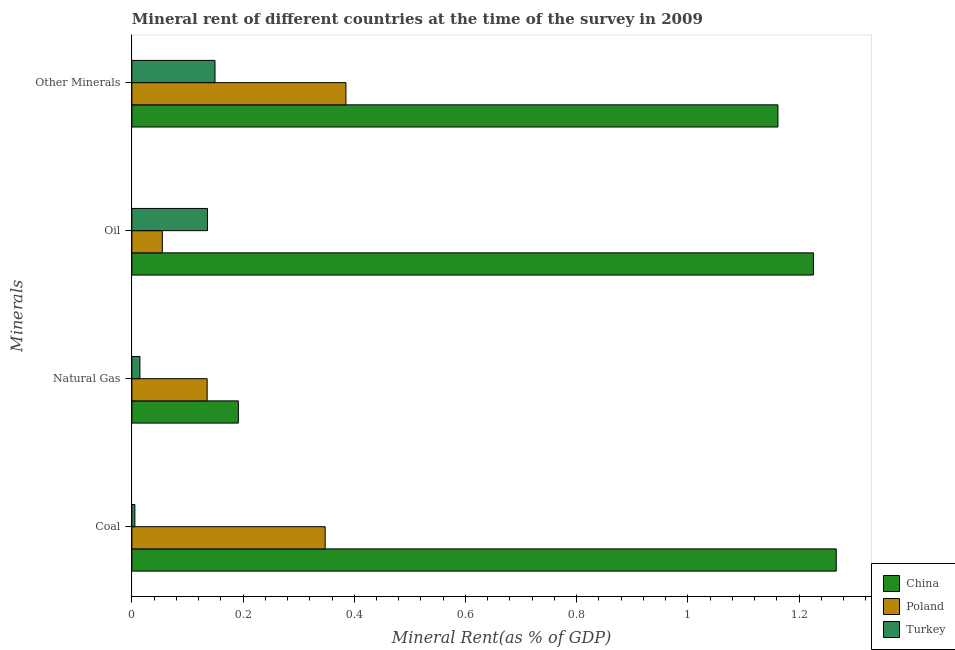Are the number of bars per tick equal to the number of legend labels?
Your response must be concise. Yes. Are the number of bars on each tick of the Y-axis equal?
Provide a succinct answer. Yes. How many bars are there on the 1st tick from the bottom?
Keep it short and to the point. 3. What is the label of the 3rd group of bars from the top?
Your response must be concise. Natural Gas. What is the coal rent in Turkey?
Offer a very short reply. 0.01. Across all countries, what is the maximum oil rent?
Provide a short and direct response. 1.23. Across all countries, what is the minimum  rent of other minerals?
Your answer should be very brief. 0.15. In which country was the natural gas rent maximum?
Ensure brevity in your answer.  China. In which country was the oil rent minimum?
Your response must be concise. Poland. What is the total  rent of other minerals in the graph?
Your answer should be very brief. 1.7. What is the difference between the natural gas rent in China and that in Turkey?
Ensure brevity in your answer.  0.18. What is the difference between the coal rent in Poland and the  rent of other minerals in Turkey?
Your response must be concise. 0.2. What is the average natural gas rent per country?
Provide a short and direct response. 0.11. What is the difference between the coal rent and  rent of other minerals in China?
Give a very brief answer. 0.1. What is the ratio of the coal rent in China to that in Poland?
Offer a very short reply. 3.64. Is the difference between the oil rent in China and Poland greater than the difference between the  rent of other minerals in China and Poland?
Keep it short and to the point. Yes. What is the difference between the highest and the second highest  rent of other minerals?
Offer a terse response. 0.78. What is the difference between the highest and the lowest coal rent?
Ensure brevity in your answer.  1.26. In how many countries, is the oil rent greater than the average oil rent taken over all countries?
Make the answer very short. 1. Is the sum of the oil rent in Poland and Turkey greater than the maximum coal rent across all countries?
Offer a terse response. No. Is it the case that in every country, the sum of the oil rent and natural gas rent is greater than the sum of coal rent and  rent of other minerals?
Keep it short and to the point. No. What does the 2nd bar from the bottom in Coal represents?
Your answer should be very brief. Poland. Is it the case that in every country, the sum of the coal rent and natural gas rent is greater than the oil rent?
Give a very brief answer. No. Are all the bars in the graph horizontal?
Your response must be concise. Yes. Does the graph contain grids?
Give a very brief answer. No. Where does the legend appear in the graph?
Your answer should be very brief. Bottom right. How many legend labels are there?
Offer a terse response. 3. How are the legend labels stacked?
Make the answer very short. Vertical. What is the title of the graph?
Make the answer very short. Mineral rent of different countries at the time of the survey in 2009. What is the label or title of the X-axis?
Keep it short and to the point. Mineral Rent(as % of GDP). What is the label or title of the Y-axis?
Your answer should be compact. Minerals. What is the Mineral Rent(as % of GDP) in China in Coal?
Your answer should be very brief. 1.27. What is the Mineral Rent(as % of GDP) in Poland in Coal?
Your answer should be compact. 0.35. What is the Mineral Rent(as % of GDP) of Turkey in Coal?
Provide a short and direct response. 0.01. What is the Mineral Rent(as % of GDP) of China in Natural Gas?
Keep it short and to the point. 0.19. What is the Mineral Rent(as % of GDP) of Poland in Natural Gas?
Offer a very short reply. 0.14. What is the Mineral Rent(as % of GDP) in Turkey in Natural Gas?
Offer a terse response. 0.01. What is the Mineral Rent(as % of GDP) of China in Oil?
Make the answer very short. 1.23. What is the Mineral Rent(as % of GDP) of Poland in Oil?
Your answer should be compact. 0.05. What is the Mineral Rent(as % of GDP) in Turkey in Oil?
Offer a terse response. 0.14. What is the Mineral Rent(as % of GDP) in China in Other Minerals?
Give a very brief answer. 1.16. What is the Mineral Rent(as % of GDP) of Poland in Other Minerals?
Make the answer very short. 0.39. What is the Mineral Rent(as % of GDP) of Turkey in Other Minerals?
Offer a terse response. 0.15. Across all Minerals, what is the maximum Mineral Rent(as % of GDP) in China?
Offer a terse response. 1.27. Across all Minerals, what is the maximum Mineral Rent(as % of GDP) in Poland?
Provide a succinct answer. 0.39. Across all Minerals, what is the maximum Mineral Rent(as % of GDP) of Turkey?
Give a very brief answer. 0.15. Across all Minerals, what is the minimum Mineral Rent(as % of GDP) of China?
Offer a very short reply. 0.19. Across all Minerals, what is the minimum Mineral Rent(as % of GDP) of Poland?
Your answer should be very brief. 0.05. Across all Minerals, what is the minimum Mineral Rent(as % of GDP) of Turkey?
Provide a short and direct response. 0.01. What is the total Mineral Rent(as % of GDP) of China in the graph?
Your answer should be very brief. 3.85. What is the total Mineral Rent(as % of GDP) of Poland in the graph?
Provide a succinct answer. 0.92. What is the total Mineral Rent(as % of GDP) in Turkey in the graph?
Make the answer very short. 0.31. What is the difference between the Mineral Rent(as % of GDP) of China in Coal and that in Natural Gas?
Your answer should be very brief. 1.08. What is the difference between the Mineral Rent(as % of GDP) of Poland in Coal and that in Natural Gas?
Keep it short and to the point. 0.21. What is the difference between the Mineral Rent(as % of GDP) in Turkey in Coal and that in Natural Gas?
Offer a terse response. -0.01. What is the difference between the Mineral Rent(as % of GDP) of China in Coal and that in Oil?
Provide a short and direct response. 0.04. What is the difference between the Mineral Rent(as % of GDP) in Poland in Coal and that in Oil?
Ensure brevity in your answer.  0.29. What is the difference between the Mineral Rent(as % of GDP) in Turkey in Coal and that in Oil?
Ensure brevity in your answer.  -0.13. What is the difference between the Mineral Rent(as % of GDP) in China in Coal and that in Other Minerals?
Ensure brevity in your answer.  0.1. What is the difference between the Mineral Rent(as % of GDP) of Poland in Coal and that in Other Minerals?
Offer a terse response. -0.04. What is the difference between the Mineral Rent(as % of GDP) of Turkey in Coal and that in Other Minerals?
Your answer should be compact. -0.14. What is the difference between the Mineral Rent(as % of GDP) in China in Natural Gas and that in Oil?
Offer a very short reply. -1.03. What is the difference between the Mineral Rent(as % of GDP) of Poland in Natural Gas and that in Oil?
Keep it short and to the point. 0.08. What is the difference between the Mineral Rent(as % of GDP) in Turkey in Natural Gas and that in Oil?
Make the answer very short. -0.12. What is the difference between the Mineral Rent(as % of GDP) of China in Natural Gas and that in Other Minerals?
Give a very brief answer. -0.97. What is the difference between the Mineral Rent(as % of GDP) in Poland in Natural Gas and that in Other Minerals?
Offer a very short reply. -0.25. What is the difference between the Mineral Rent(as % of GDP) in Turkey in Natural Gas and that in Other Minerals?
Give a very brief answer. -0.14. What is the difference between the Mineral Rent(as % of GDP) in China in Oil and that in Other Minerals?
Your answer should be compact. 0.06. What is the difference between the Mineral Rent(as % of GDP) in Poland in Oil and that in Other Minerals?
Make the answer very short. -0.33. What is the difference between the Mineral Rent(as % of GDP) of Turkey in Oil and that in Other Minerals?
Keep it short and to the point. -0.01. What is the difference between the Mineral Rent(as % of GDP) in China in Coal and the Mineral Rent(as % of GDP) in Poland in Natural Gas?
Offer a very short reply. 1.13. What is the difference between the Mineral Rent(as % of GDP) of China in Coal and the Mineral Rent(as % of GDP) of Turkey in Natural Gas?
Give a very brief answer. 1.25. What is the difference between the Mineral Rent(as % of GDP) of Poland in Coal and the Mineral Rent(as % of GDP) of Turkey in Natural Gas?
Offer a very short reply. 0.33. What is the difference between the Mineral Rent(as % of GDP) of China in Coal and the Mineral Rent(as % of GDP) of Poland in Oil?
Provide a succinct answer. 1.21. What is the difference between the Mineral Rent(as % of GDP) of China in Coal and the Mineral Rent(as % of GDP) of Turkey in Oil?
Offer a terse response. 1.13. What is the difference between the Mineral Rent(as % of GDP) of Poland in Coal and the Mineral Rent(as % of GDP) of Turkey in Oil?
Your answer should be compact. 0.21. What is the difference between the Mineral Rent(as % of GDP) of China in Coal and the Mineral Rent(as % of GDP) of Poland in Other Minerals?
Make the answer very short. 0.88. What is the difference between the Mineral Rent(as % of GDP) of China in Coal and the Mineral Rent(as % of GDP) of Turkey in Other Minerals?
Offer a terse response. 1.12. What is the difference between the Mineral Rent(as % of GDP) of Poland in Coal and the Mineral Rent(as % of GDP) of Turkey in Other Minerals?
Offer a very short reply. 0.2. What is the difference between the Mineral Rent(as % of GDP) of China in Natural Gas and the Mineral Rent(as % of GDP) of Poland in Oil?
Keep it short and to the point. 0.14. What is the difference between the Mineral Rent(as % of GDP) in China in Natural Gas and the Mineral Rent(as % of GDP) in Turkey in Oil?
Keep it short and to the point. 0.06. What is the difference between the Mineral Rent(as % of GDP) of Poland in Natural Gas and the Mineral Rent(as % of GDP) of Turkey in Oil?
Give a very brief answer. -0. What is the difference between the Mineral Rent(as % of GDP) of China in Natural Gas and the Mineral Rent(as % of GDP) of Poland in Other Minerals?
Provide a succinct answer. -0.19. What is the difference between the Mineral Rent(as % of GDP) of China in Natural Gas and the Mineral Rent(as % of GDP) of Turkey in Other Minerals?
Ensure brevity in your answer.  0.04. What is the difference between the Mineral Rent(as % of GDP) in Poland in Natural Gas and the Mineral Rent(as % of GDP) in Turkey in Other Minerals?
Your answer should be compact. -0.01. What is the difference between the Mineral Rent(as % of GDP) in China in Oil and the Mineral Rent(as % of GDP) in Poland in Other Minerals?
Keep it short and to the point. 0.84. What is the difference between the Mineral Rent(as % of GDP) of China in Oil and the Mineral Rent(as % of GDP) of Turkey in Other Minerals?
Provide a succinct answer. 1.08. What is the difference between the Mineral Rent(as % of GDP) in Poland in Oil and the Mineral Rent(as % of GDP) in Turkey in Other Minerals?
Your answer should be very brief. -0.09. What is the average Mineral Rent(as % of GDP) in China per Minerals?
Your response must be concise. 0.96. What is the average Mineral Rent(as % of GDP) of Poland per Minerals?
Give a very brief answer. 0.23. What is the average Mineral Rent(as % of GDP) in Turkey per Minerals?
Give a very brief answer. 0.08. What is the difference between the Mineral Rent(as % of GDP) of China and Mineral Rent(as % of GDP) of Poland in Coal?
Make the answer very short. 0.92. What is the difference between the Mineral Rent(as % of GDP) in China and Mineral Rent(as % of GDP) in Turkey in Coal?
Ensure brevity in your answer.  1.26. What is the difference between the Mineral Rent(as % of GDP) in Poland and Mineral Rent(as % of GDP) in Turkey in Coal?
Offer a terse response. 0.34. What is the difference between the Mineral Rent(as % of GDP) in China and Mineral Rent(as % of GDP) in Poland in Natural Gas?
Provide a succinct answer. 0.06. What is the difference between the Mineral Rent(as % of GDP) in China and Mineral Rent(as % of GDP) in Turkey in Natural Gas?
Provide a short and direct response. 0.18. What is the difference between the Mineral Rent(as % of GDP) of Poland and Mineral Rent(as % of GDP) of Turkey in Natural Gas?
Provide a succinct answer. 0.12. What is the difference between the Mineral Rent(as % of GDP) in China and Mineral Rent(as % of GDP) in Poland in Oil?
Provide a short and direct response. 1.17. What is the difference between the Mineral Rent(as % of GDP) of China and Mineral Rent(as % of GDP) of Turkey in Oil?
Your answer should be very brief. 1.09. What is the difference between the Mineral Rent(as % of GDP) of Poland and Mineral Rent(as % of GDP) of Turkey in Oil?
Ensure brevity in your answer.  -0.08. What is the difference between the Mineral Rent(as % of GDP) in China and Mineral Rent(as % of GDP) in Poland in Other Minerals?
Your answer should be compact. 0.78. What is the difference between the Mineral Rent(as % of GDP) in China and Mineral Rent(as % of GDP) in Turkey in Other Minerals?
Offer a very short reply. 1.01. What is the difference between the Mineral Rent(as % of GDP) of Poland and Mineral Rent(as % of GDP) of Turkey in Other Minerals?
Your answer should be compact. 0.24. What is the ratio of the Mineral Rent(as % of GDP) of China in Coal to that in Natural Gas?
Offer a terse response. 6.61. What is the ratio of the Mineral Rent(as % of GDP) in Poland in Coal to that in Natural Gas?
Ensure brevity in your answer.  2.57. What is the ratio of the Mineral Rent(as % of GDP) of Turkey in Coal to that in Natural Gas?
Offer a terse response. 0.37. What is the ratio of the Mineral Rent(as % of GDP) of China in Coal to that in Oil?
Ensure brevity in your answer.  1.03. What is the ratio of the Mineral Rent(as % of GDP) in Poland in Coal to that in Oil?
Provide a short and direct response. 6.35. What is the ratio of the Mineral Rent(as % of GDP) in Turkey in Coal to that in Oil?
Make the answer very short. 0.04. What is the ratio of the Mineral Rent(as % of GDP) in China in Coal to that in Other Minerals?
Keep it short and to the point. 1.09. What is the ratio of the Mineral Rent(as % of GDP) in Poland in Coal to that in Other Minerals?
Provide a succinct answer. 0.9. What is the ratio of the Mineral Rent(as % of GDP) of Turkey in Coal to that in Other Minerals?
Keep it short and to the point. 0.04. What is the ratio of the Mineral Rent(as % of GDP) of China in Natural Gas to that in Oil?
Offer a terse response. 0.16. What is the ratio of the Mineral Rent(as % of GDP) of Poland in Natural Gas to that in Oil?
Provide a succinct answer. 2.47. What is the ratio of the Mineral Rent(as % of GDP) in Turkey in Natural Gas to that in Oil?
Your answer should be compact. 0.11. What is the ratio of the Mineral Rent(as % of GDP) in China in Natural Gas to that in Other Minerals?
Your answer should be very brief. 0.16. What is the ratio of the Mineral Rent(as % of GDP) of Poland in Natural Gas to that in Other Minerals?
Provide a short and direct response. 0.35. What is the ratio of the Mineral Rent(as % of GDP) in Turkey in Natural Gas to that in Other Minerals?
Give a very brief answer. 0.1. What is the ratio of the Mineral Rent(as % of GDP) of China in Oil to that in Other Minerals?
Offer a very short reply. 1.05. What is the ratio of the Mineral Rent(as % of GDP) of Poland in Oil to that in Other Minerals?
Keep it short and to the point. 0.14. What is the ratio of the Mineral Rent(as % of GDP) of Turkey in Oil to that in Other Minerals?
Provide a short and direct response. 0.91. What is the difference between the highest and the second highest Mineral Rent(as % of GDP) in China?
Provide a succinct answer. 0.04. What is the difference between the highest and the second highest Mineral Rent(as % of GDP) in Poland?
Give a very brief answer. 0.04. What is the difference between the highest and the second highest Mineral Rent(as % of GDP) in Turkey?
Offer a very short reply. 0.01. What is the difference between the highest and the lowest Mineral Rent(as % of GDP) of China?
Your answer should be very brief. 1.08. What is the difference between the highest and the lowest Mineral Rent(as % of GDP) of Poland?
Make the answer very short. 0.33. What is the difference between the highest and the lowest Mineral Rent(as % of GDP) of Turkey?
Your answer should be very brief. 0.14. 